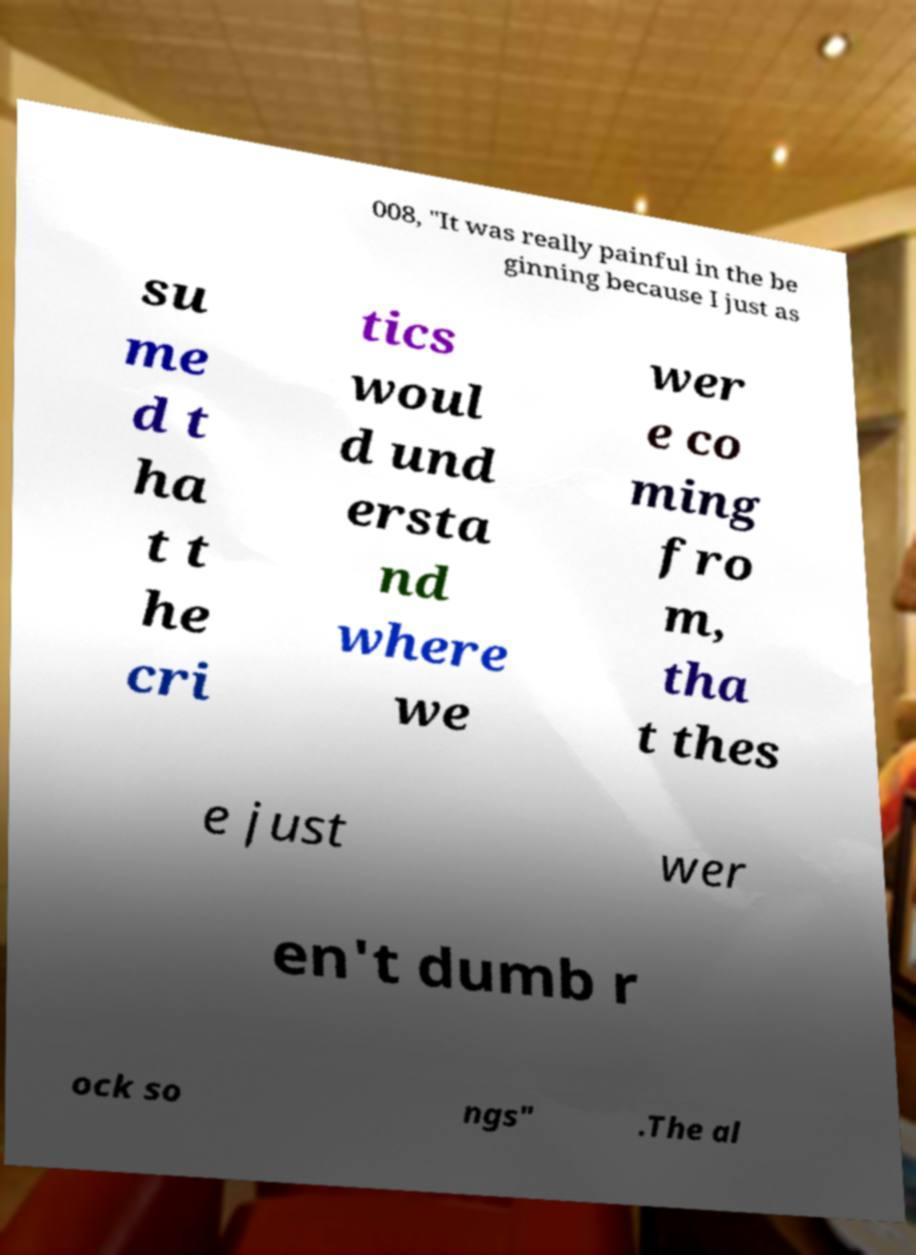Can you read and provide the text displayed in the image?This photo seems to have some interesting text. Can you extract and type it out for me? 008, "It was really painful in the be ginning because I just as su me d t ha t t he cri tics woul d und ersta nd where we wer e co ming fro m, tha t thes e just wer en't dumb r ock so ngs" .The al 